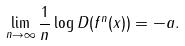<formula> <loc_0><loc_0><loc_500><loc_500>\lim _ { n \to \infty } \frac { 1 } { n } \log D ( f ^ { n } ( x ) ) = - a .</formula> 